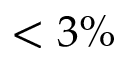<formula> <loc_0><loc_0><loc_500><loc_500>< 3 \%</formula> 